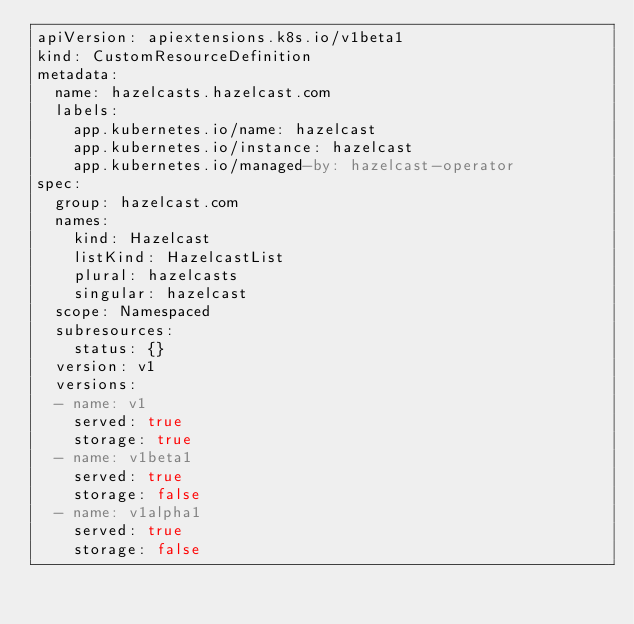<code> <loc_0><loc_0><loc_500><loc_500><_YAML_>apiVersion: apiextensions.k8s.io/v1beta1
kind: CustomResourceDefinition
metadata:
  name: hazelcasts.hazelcast.com
  labels:
    app.kubernetes.io/name: hazelcast
    app.kubernetes.io/instance: hazelcast
    app.kubernetes.io/managed-by: hazelcast-operator
spec:
  group: hazelcast.com
  names:
    kind: Hazelcast
    listKind: HazelcastList
    plural: hazelcasts
    singular: hazelcast
  scope: Namespaced
  subresources:
    status: {}
  version: v1
  versions:
  - name: v1
    served: true
    storage: true
  - name: v1beta1
    served: true
    storage: false
  - name: v1alpha1
    served: true
    storage: false
</code> 